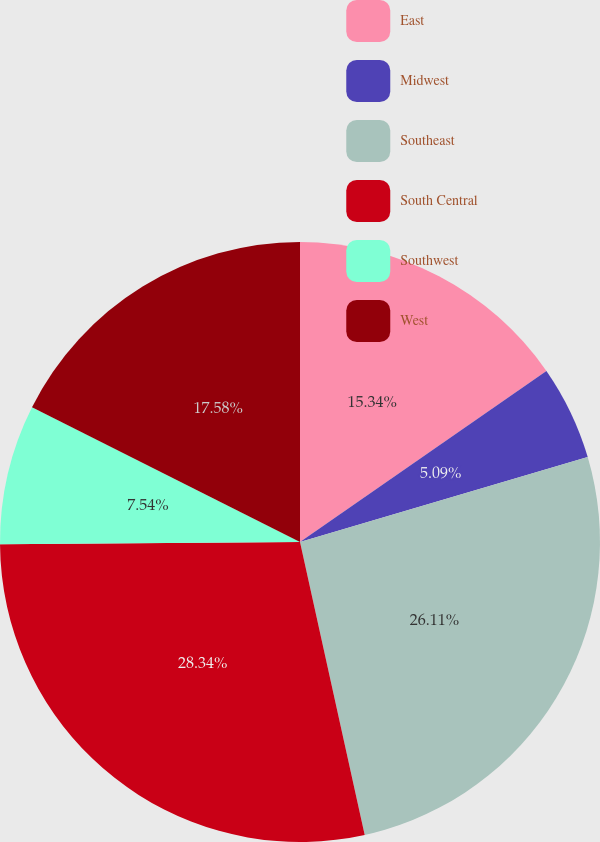Convert chart to OTSL. <chart><loc_0><loc_0><loc_500><loc_500><pie_chart><fcel>East<fcel>Midwest<fcel>Southeast<fcel>South Central<fcel>Southwest<fcel>West<nl><fcel>15.34%<fcel>5.09%<fcel>26.11%<fcel>28.34%<fcel>7.54%<fcel>17.58%<nl></chart> 